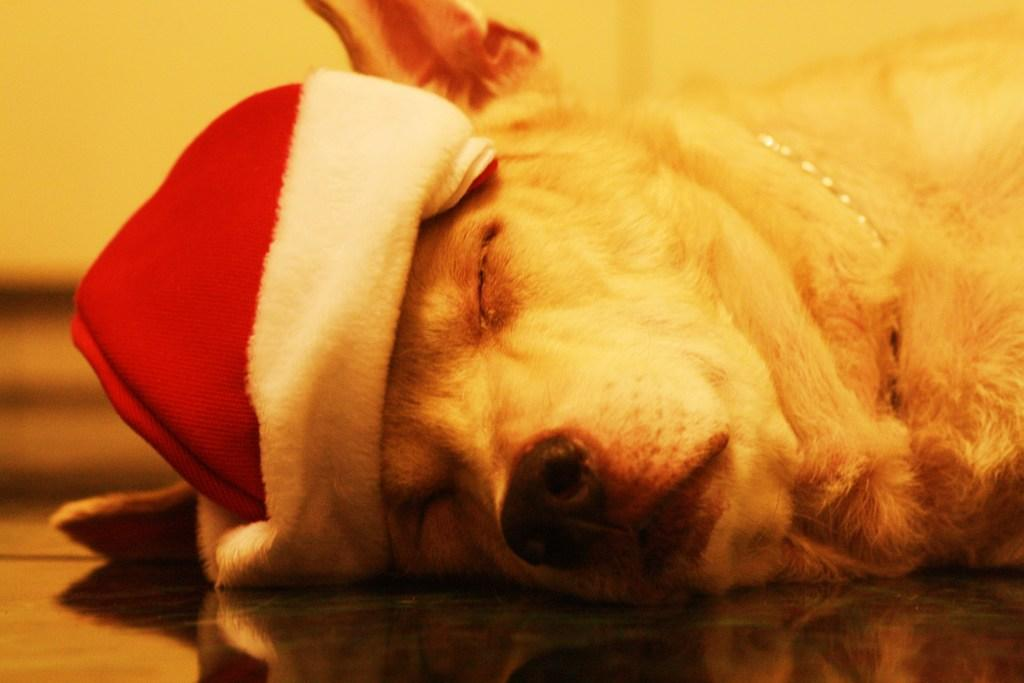What type of animal is present in the image? There is a dog in the image. What is the dog doing in the image? The dog is sleeping on the floor. Is the dog wearing any accessories in the image? Yes, the dog is wearing a red color cap. How many wings does the dog have in the image? The dog does not have any wings in the image; it is a dog, not a bird. 